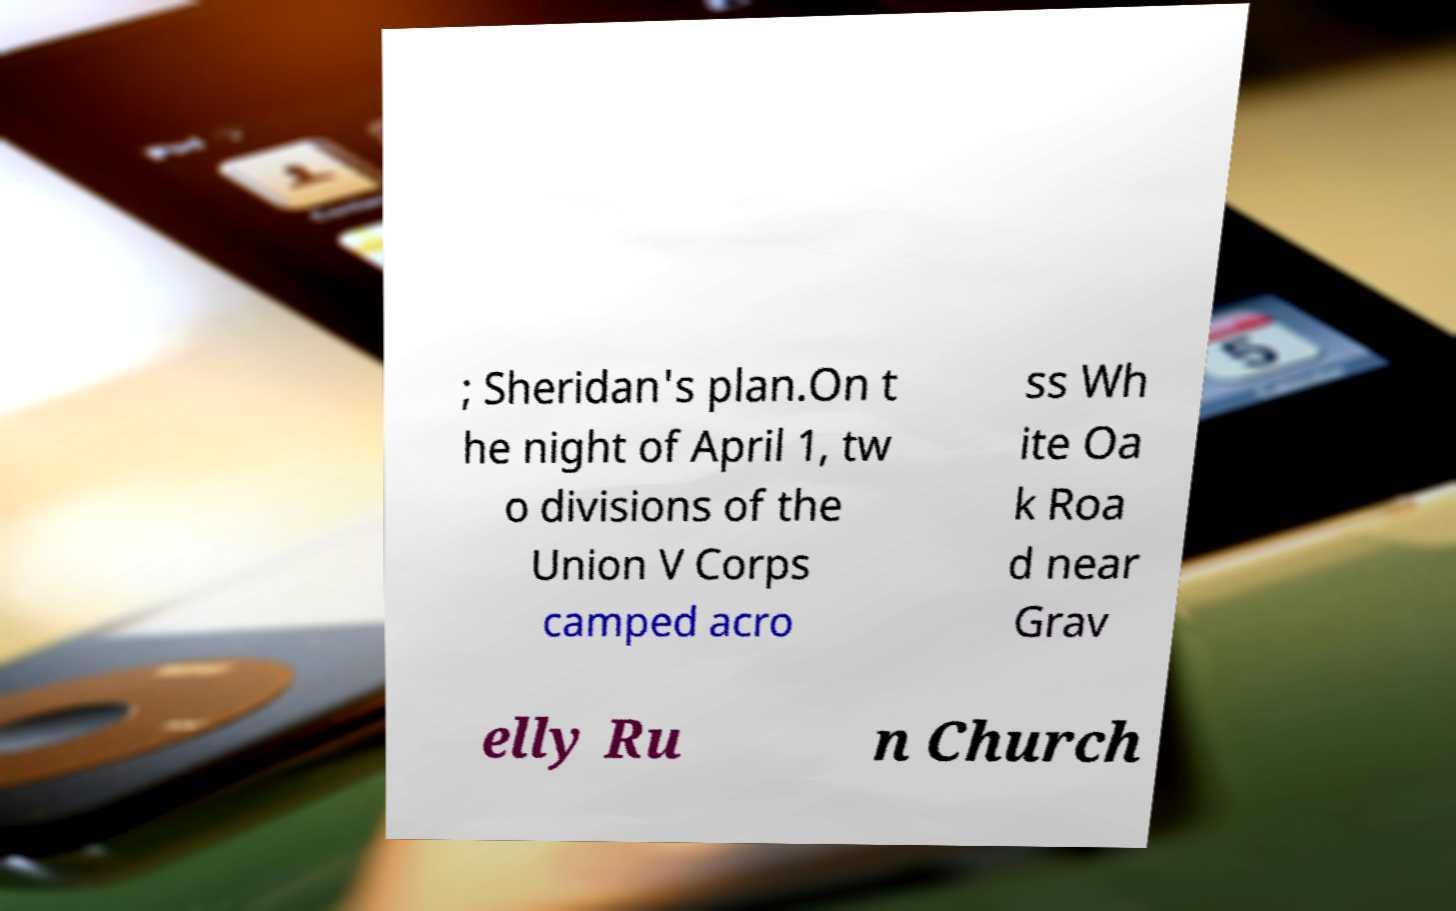Can you accurately transcribe the text from the provided image for me? ; Sheridan's plan.On t he night of April 1, tw o divisions of the Union V Corps camped acro ss Wh ite Oa k Roa d near Grav elly Ru n Church 